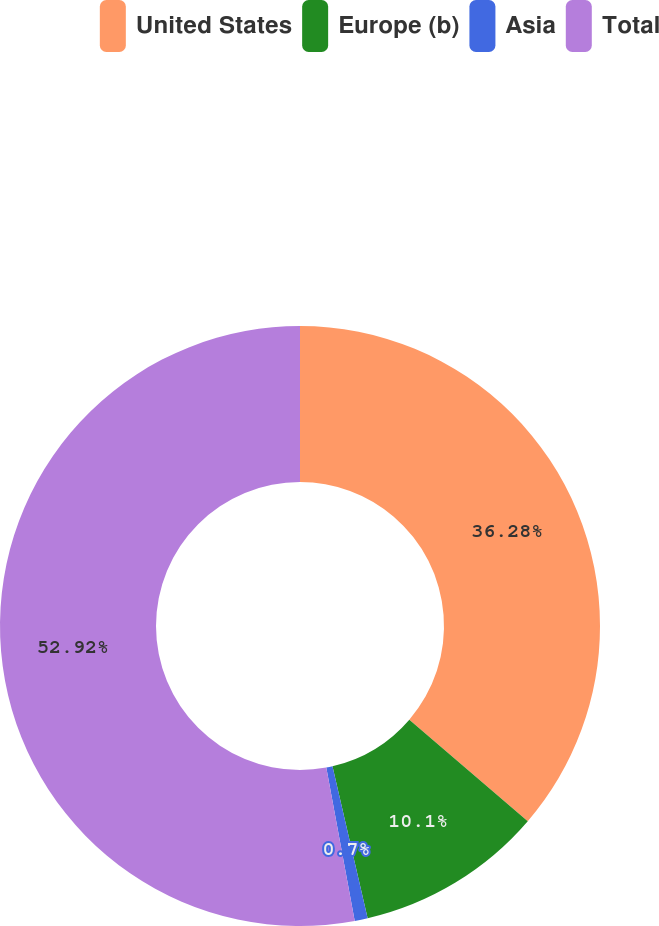Convert chart. <chart><loc_0><loc_0><loc_500><loc_500><pie_chart><fcel>United States<fcel>Europe (b)<fcel>Asia<fcel>Total<nl><fcel>36.28%<fcel>10.1%<fcel>0.7%<fcel>52.92%<nl></chart> 